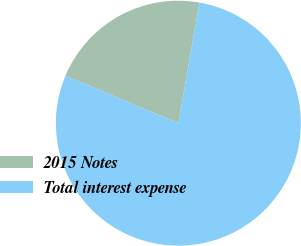Convert chart to OTSL. <chart><loc_0><loc_0><loc_500><loc_500><pie_chart><fcel>2015 Notes<fcel>Total interest expense<nl><fcel>21.43%<fcel>78.57%<nl></chart> 